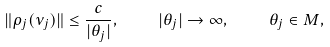Convert formula to latex. <formula><loc_0><loc_0><loc_500><loc_500>\| \rho _ { j } ( \nu _ { j } ) \| \leq \frac { c } { | \theta _ { j } | } , \quad | \theta _ { j } | \to \infty , \quad \theta _ { j } \in M ,</formula> 